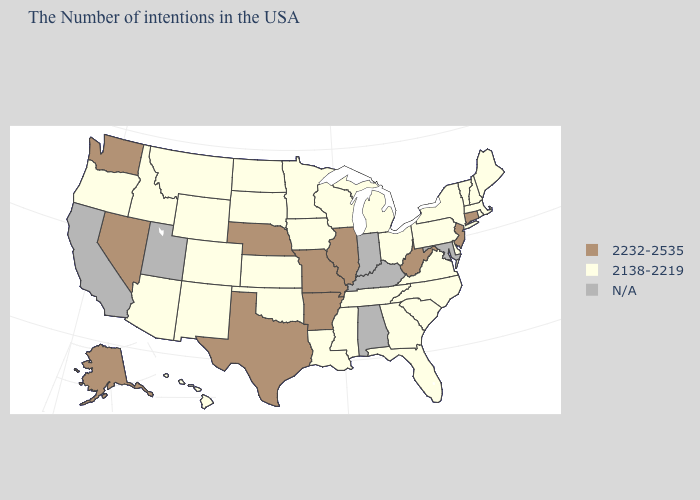Does Montana have the highest value in the USA?
Write a very short answer. No. Name the states that have a value in the range 2138-2219?
Concise answer only. Maine, Massachusetts, Rhode Island, New Hampshire, Vermont, New York, Delaware, Pennsylvania, Virginia, North Carolina, South Carolina, Ohio, Florida, Georgia, Michigan, Tennessee, Wisconsin, Mississippi, Louisiana, Minnesota, Iowa, Kansas, Oklahoma, South Dakota, North Dakota, Wyoming, Colorado, New Mexico, Montana, Arizona, Idaho, Oregon, Hawaii. What is the value of Alabama?
Answer briefly. N/A. What is the highest value in states that border Rhode Island?
Give a very brief answer. 2232-2535. What is the lowest value in the USA?
Answer briefly. 2138-2219. Name the states that have a value in the range N/A?
Be succinct. Maryland, Kentucky, Indiana, Alabama, Utah, California. Name the states that have a value in the range 2232-2535?
Short answer required. Connecticut, New Jersey, West Virginia, Illinois, Missouri, Arkansas, Nebraska, Texas, Nevada, Washington, Alaska. Among the states that border Louisiana , which have the highest value?
Give a very brief answer. Arkansas, Texas. What is the value of Georgia?
Give a very brief answer. 2138-2219. What is the highest value in the USA?
Quick response, please. 2232-2535. Among the states that border Maryland , which have the lowest value?
Be succinct. Delaware, Pennsylvania, Virginia. What is the highest value in the USA?
Keep it brief. 2232-2535. What is the lowest value in states that border Virginia?
Quick response, please. 2138-2219. What is the value of Wisconsin?
Quick response, please. 2138-2219. Among the states that border Mississippi , which have the lowest value?
Keep it brief. Tennessee, Louisiana. 